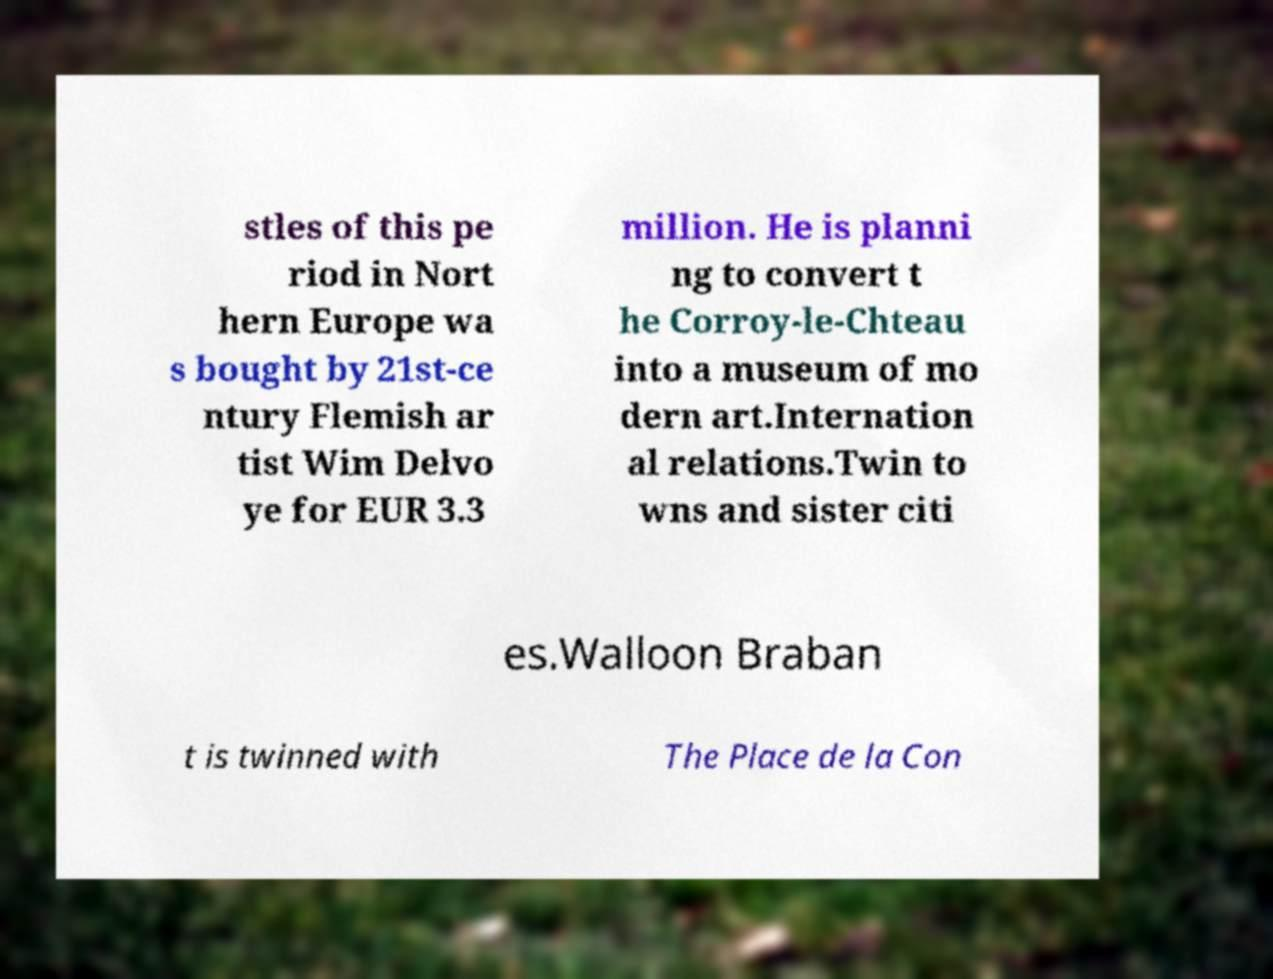Can you read and provide the text displayed in the image?This photo seems to have some interesting text. Can you extract and type it out for me? stles of this pe riod in Nort hern Europe wa s bought by 21st-ce ntury Flemish ar tist Wim Delvo ye for EUR 3.3 million. He is planni ng to convert t he Corroy-le-Chteau into a museum of mo dern art.Internation al relations.Twin to wns and sister citi es.Walloon Braban t is twinned with The Place de la Con 